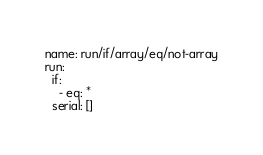Convert code to text. <code><loc_0><loc_0><loc_500><loc_500><_YAML_>name: run/if/array/eq/not-array
run:
  if:
    - eq: *
  serial: []</code> 